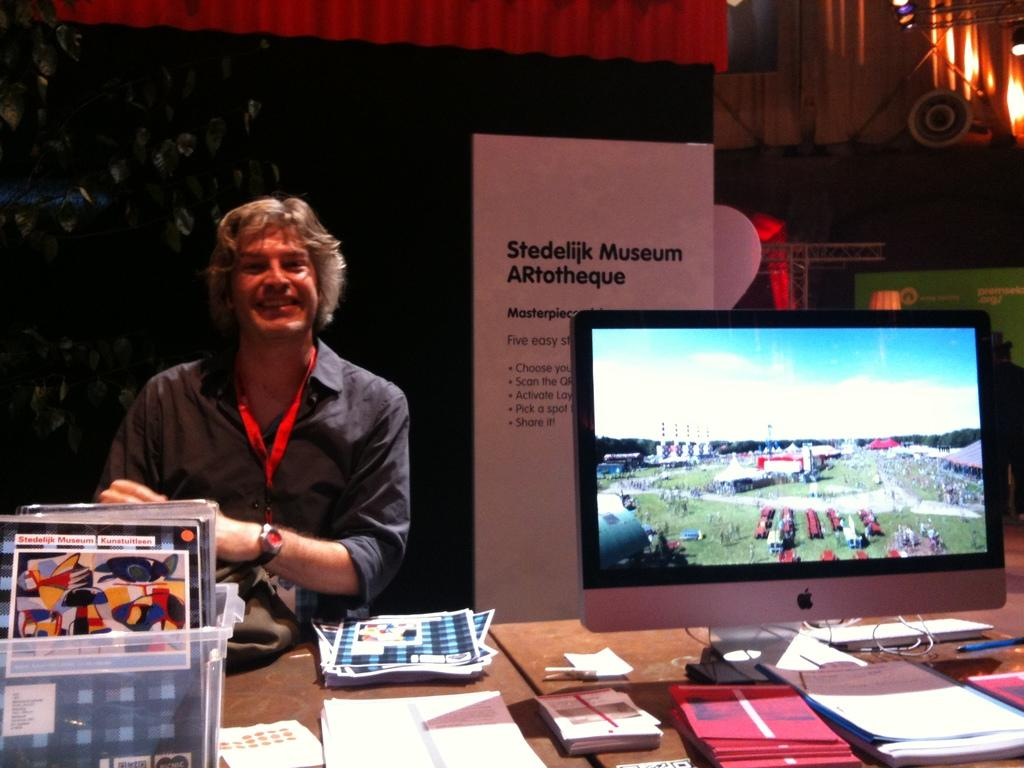<image>
Offer a succinct explanation of the picture presented. A man stand in front of a sign that reads Stedelijk Museum 